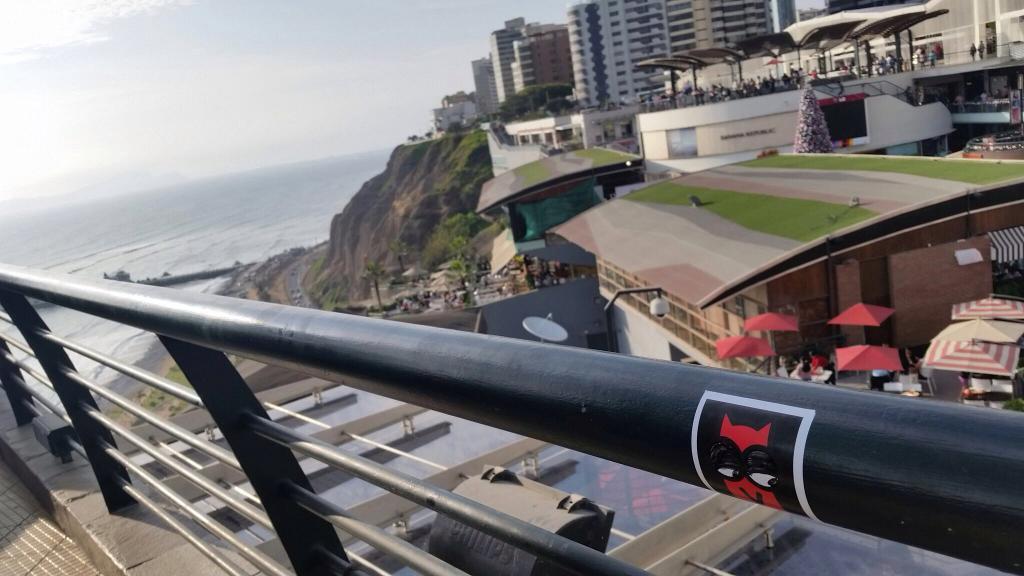What type of structure can be seen in the image? There is a railing in the image. What else is visible in the image besides the railing? There are many buildings, tents, trees, and people in the image. Can you describe the water visible in the image? There is water visible to the left of the image. What is visible in the background of the image? The sky is visible in the background of the image. How many turkeys are present in the image? There are no turkeys present in the image. What type of fowl can be seen flying in the image? There is no fowl visible in the image. 